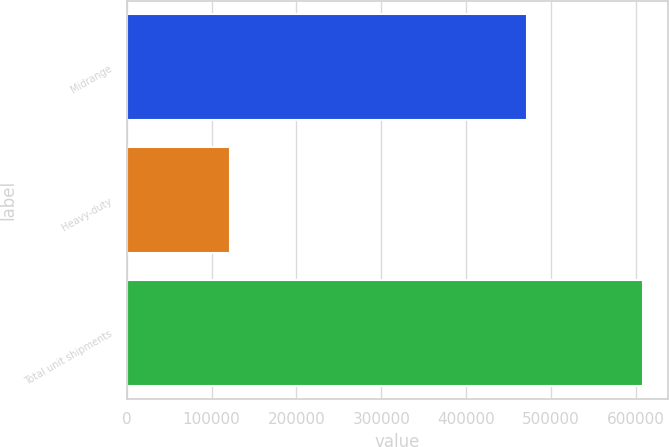Convert chart to OTSL. <chart><loc_0><loc_0><loc_500><loc_500><bar_chart><fcel>Midrange<fcel>Heavy-duty<fcel>Total unit shipments<nl><fcel>471200<fcel>122100<fcel>608100<nl></chart> 